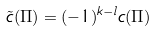Convert formula to latex. <formula><loc_0><loc_0><loc_500><loc_500>\tilde { c } ( \Pi ) = ( - 1 ) ^ { k - l } c ( \Pi )</formula> 